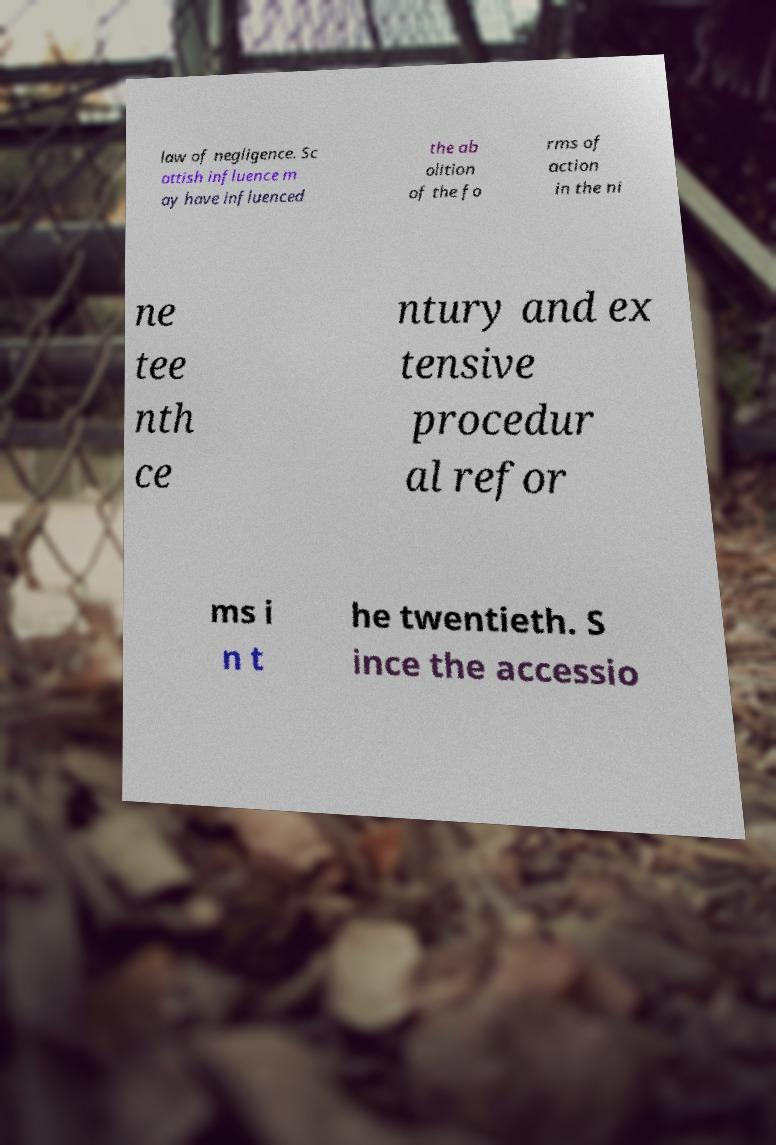There's text embedded in this image that I need extracted. Can you transcribe it verbatim? law of negligence. Sc ottish influence m ay have influenced the ab olition of the fo rms of action in the ni ne tee nth ce ntury and ex tensive procedur al refor ms i n t he twentieth. S ince the accessio 